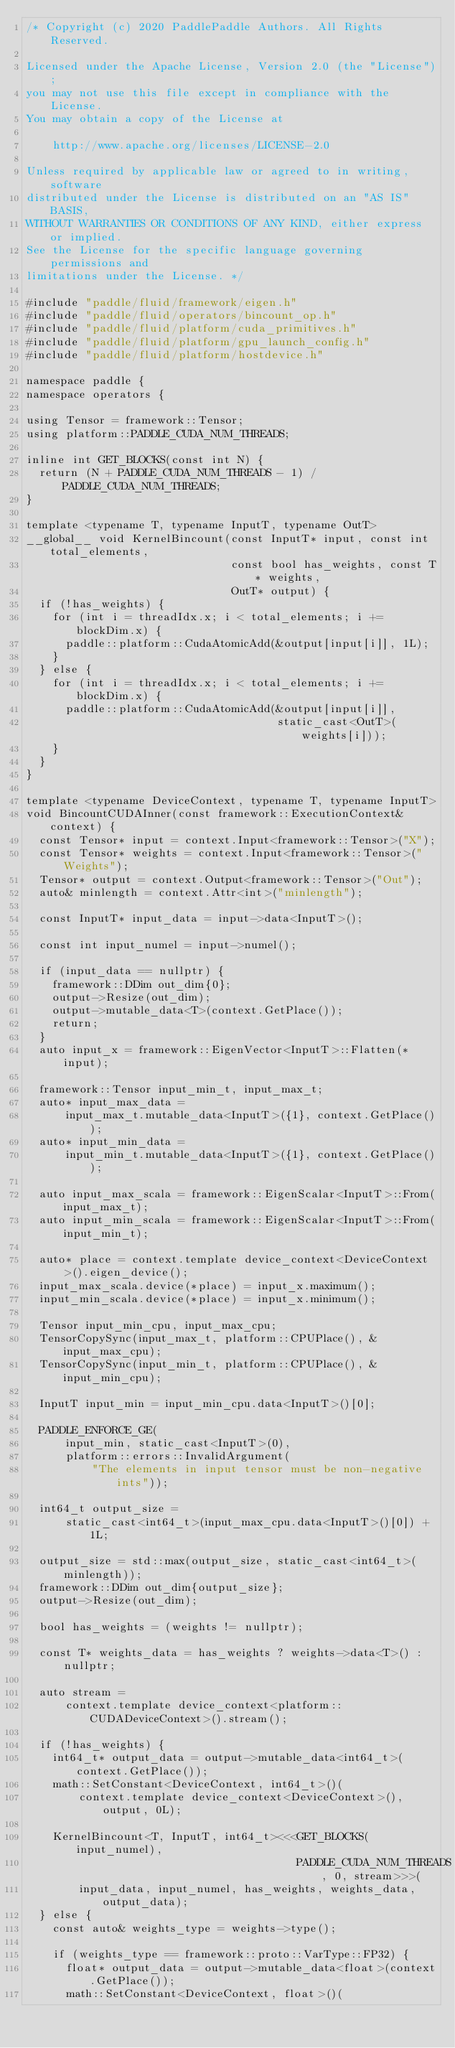<code> <loc_0><loc_0><loc_500><loc_500><_Cuda_>/* Copyright (c) 2020 PaddlePaddle Authors. All Rights Reserved.

Licensed under the Apache License, Version 2.0 (the "License");
you may not use this file except in compliance with the License.
You may obtain a copy of the License at

    http://www.apache.org/licenses/LICENSE-2.0

Unless required by applicable law or agreed to in writing, software
distributed under the License is distributed on an "AS IS" BASIS,
WITHOUT WARRANTIES OR CONDITIONS OF ANY KIND, either express or implied.
See the License for the specific language governing permissions and
limitations under the License. */

#include "paddle/fluid/framework/eigen.h"
#include "paddle/fluid/operators/bincount_op.h"
#include "paddle/fluid/platform/cuda_primitives.h"
#include "paddle/fluid/platform/gpu_launch_config.h"
#include "paddle/fluid/platform/hostdevice.h"

namespace paddle {
namespace operators {

using Tensor = framework::Tensor;
using platform::PADDLE_CUDA_NUM_THREADS;

inline int GET_BLOCKS(const int N) {
  return (N + PADDLE_CUDA_NUM_THREADS - 1) / PADDLE_CUDA_NUM_THREADS;
}

template <typename T, typename InputT, typename OutT>
__global__ void KernelBincount(const InputT* input, const int total_elements,
                               const bool has_weights, const T* weights,
                               OutT* output) {
  if (!has_weights) {
    for (int i = threadIdx.x; i < total_elements; i += blockDim.x) {
      paddle::platform::CudaAtomicAdd(&output[input[i]], 1L);
    }
  } else {
    for (int i = threadIdx.x; i < total_elements; i += blockDim.x) {
      paddle::platform::CudaAtomicAdd(&output[input[i]],
                                      static_cast<OutT>(weights[i]));
    }
  }
}

template <typename DeviceContext, typename T, typename InputT>
void BincountCUDAInner(const framework::ExecutionContext& context) {
  const Tensor* input = context.Input<framework::Tensor>("X");
  const Tensor* weights = context.Input<framework::Tensor>("Weights");
  Tensor* output = context.Output<framework::Tensor>("Out");
  auto& minlength = context.Attr<int>("minlength");

  const InputT* input_data = input->data<InputT>();

  const int input_numel = input->numel();

  if (input_data == nullptr) {
    framework::DDim out_dim{0};
    output->Resize(out_dim);
    output->mutable_data<T>(context.GetPlace());
    return;
  }
  auto input_x = framework::EigenVector<InputT>::Flatten(*input);

  framework::Tensor input_min_t, input_max_t;
  auto* input_max_data =
      input_max_t.mutable_data<InputT>({1}, context.GetPlace());
  auto* input_min_data =
      input_min_t.mutable_data<InputT>({1}, context.GetPlace());

  auto input_max_scala = framework::EigenScalar<InputT>::From(input_max_t);
  auto input_min_scala = framework::EigenScalar<InputT>::From(input_min_t);

  auto* place = context.template device_context<DeviceContext>().eigen_device();
  input_max_scala.device(*place) = input_x.maximum();
  input_min_scala.device(*place) = input_x.minimum();

  Tensor input_min_cpu, input_max_cpu;
  TensorCopySync(input_max_t, platform::CPUPlace(), &input_max_cpu);
  TensorCopySync(input_min_t, platform::CPUPlace(), &input_min_cpu);

  InputT input_min = input_min_cpu.data<InputT>()[0];

  PADDLE_ENFORCE_GE(
      input_min, static_cast<InputT>(0),
      platform::errors::InvalidArgument(
          "The elements in input tensor must be non-negative ints"));

  int64_t output_size =
      static_cast<int64_t>(input_max_cpu.data<InputT>()[0]) + 1L;

  output_size = std::max(output_size, static_cast<int64_t>(minlength));
  framework::DDim out_dim{output_size};
  output->Resize(out_dim);

  bool has_weights = (weights != nullptr);

  const T* weights_data = has_weights ? weights->data<T>() : nullptr;

  auto stream =
      context.template device_context<platform::CUDADeviceContext>().stream();

  if (!has_weights) {
    int64_t* output_data = output->mutable_data<int64_t>(context.GetPlace());
    math::SetConstant<DeviceContext, int64_t>()(
        context.template device_context<DeviceContext>(), output, 0L);

    KernelBincount<T, InputT, int64_t><<<GET_BLOCKS(input_numel),
                                         PADDLE_CUDA_NUM_THREADS, 0, stream>>>(
        input_data, input_numel, has_weights, weights_data, output_data);
  } else {
    const auto& weights_type = weights->type();

    if (weights_type == framework::proto::VarType::FP32) {
      float* output_data = output->mutable_data<float>(context.GetPlace());
      math::SetConstant<DeviceContext, float>()(</code> 